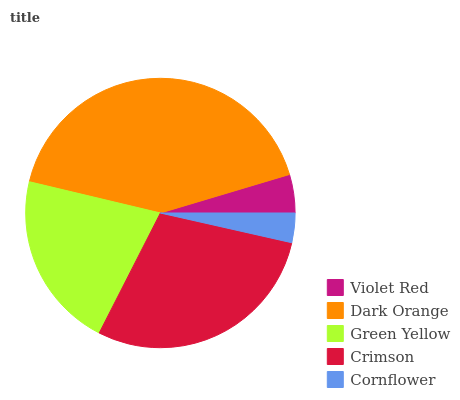Is Cornflower the minimum?
Answer yes or no. Yes. Is Dark Orange the maximum?
Answer yes or no. Yes. Is Green Yellow the minimum?
Answer yes or no. No. Is Green Yellow the maximum?
Answer yes or no. No. Is Dark Orange greater than Green Yellow?
Answer yes or no. Yes. Is Green Yellow less than Dark Orange?
Answer yes or no. Yes. Is Green Yellow greater than Dark Orange?
Answer yes or no. No. Is Dark Orange less than Green Yellow?
Answer yes or no. No. Is Green Yellow the high median?
Answer yes or no. Yes. Is Green Yellow the low median?
Answer yes or no. Yes. Is Cornflower the high median?
Answer yes or no. No. Is Cornflower the low median?
Answer yes or no. No. 